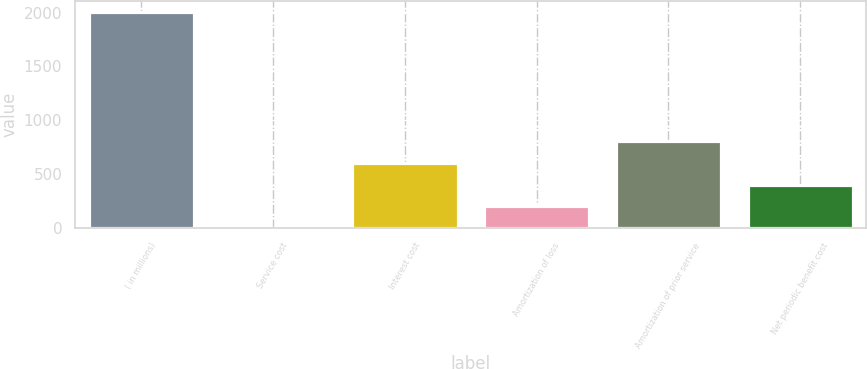Convert chart. <chart><loc_0><loc_0><loc_500><loc_500><bar_chart><fcel>( in millions)<fcel>Service cost<fcel>Interest cost<fcel>Amortization of loss<fcel>Amortization of prior service<fcel>Net periodic benefit cost<nl><fcel>2007<fcel>1.2<fcel>602.94<fcel>201.78<fcel>803.52<fcel>402.36<nl></chart> 